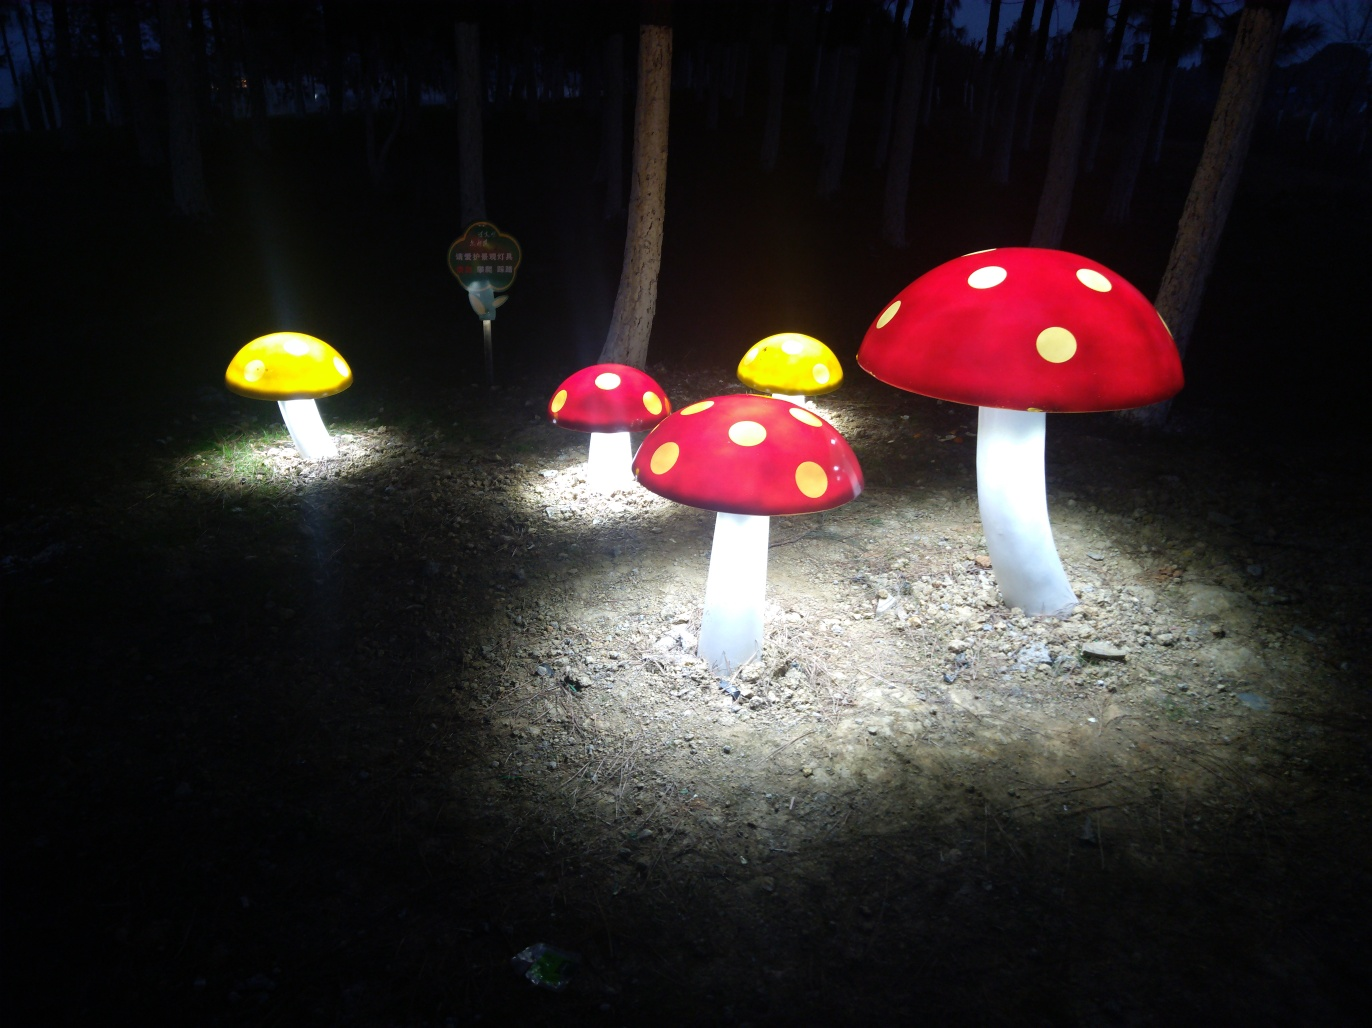Are there any focusing issues in this image? The image appears to be in focus, with the illuminated mushrooms sharp and clear against the dark background. The lighting provides a pleasant contrast and depth to the scene, with no observable focusing issues. 